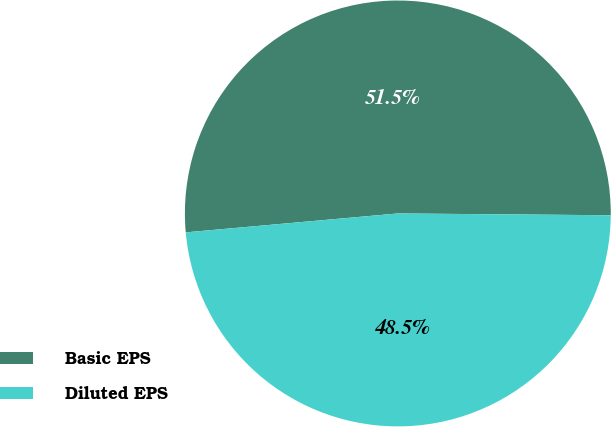<chart> <loc_0><loc_0><loc_500><loc_500><pie_chart><fcel>Basic EPS<fcel>Diluted EPS<nl><fcel>51.55%<fcel>48.45%<nl></chart> 